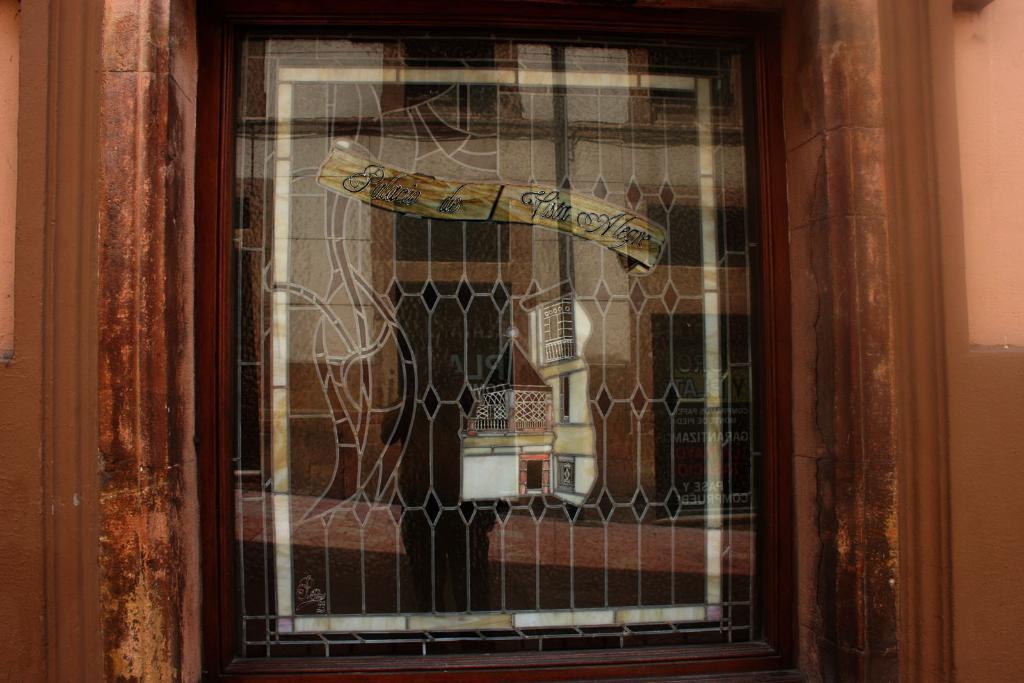What type of window is visible in the image? There is a glass window in the image. What design is featured on the glass window? The glass window has a design of a house on it. How many caps are visible on the glass window in the image? There are no caps present on the glass window in the image. 